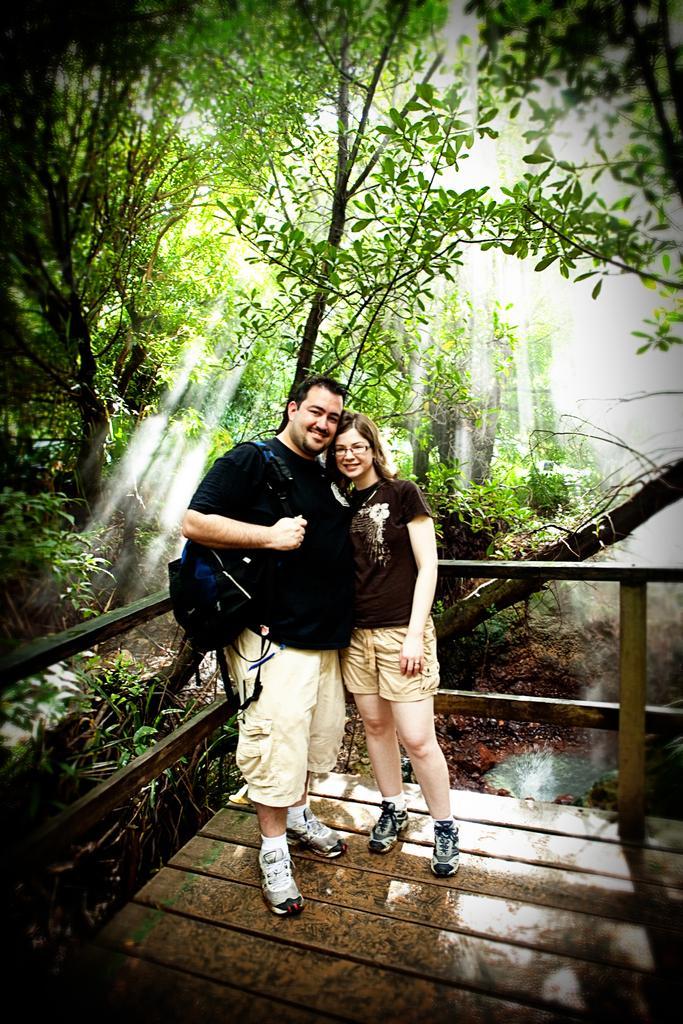Could you give a brief overview of what you see in this image? In this image I can see two persons are standing and I can see smile on their faces. On the left side I can see he is carrying a bag and in the background I can see number of trees. 